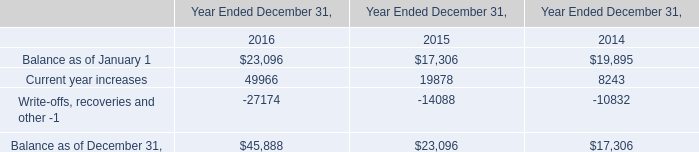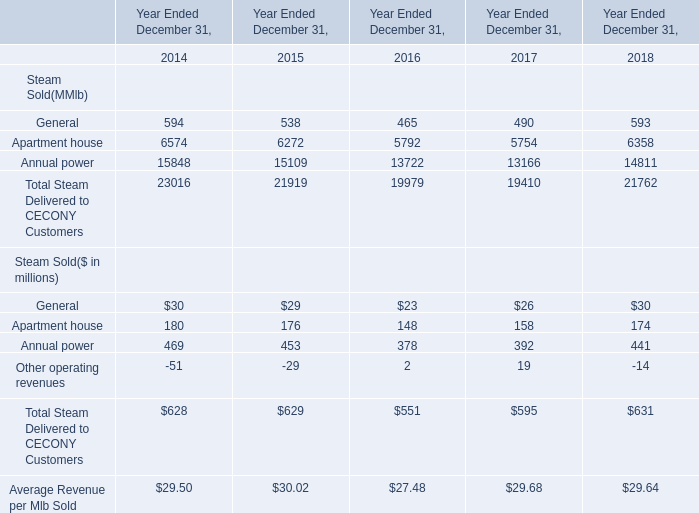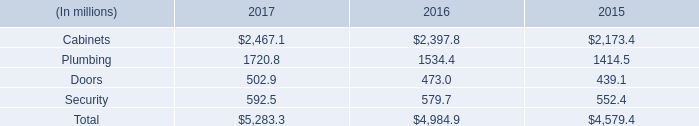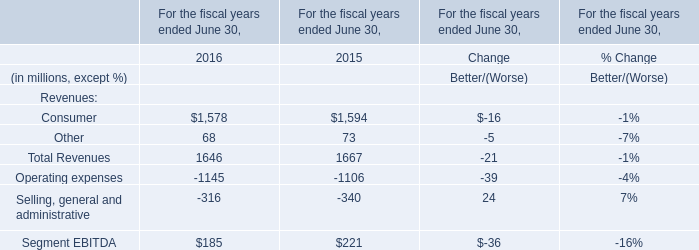Which year is Total Steam Delivered to CECONY Customers the most? 
Answer: 2014. 